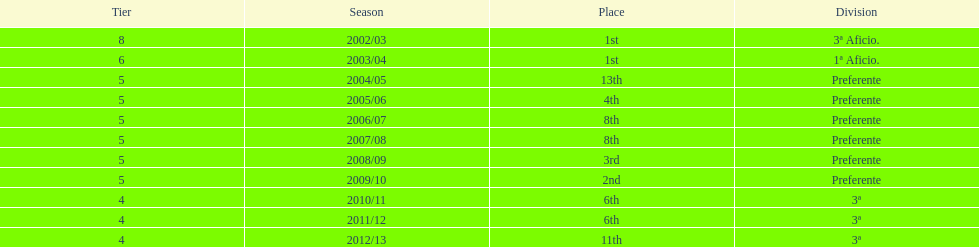How many seasons did internacional de madrid cf play in the preferente division? 6. 